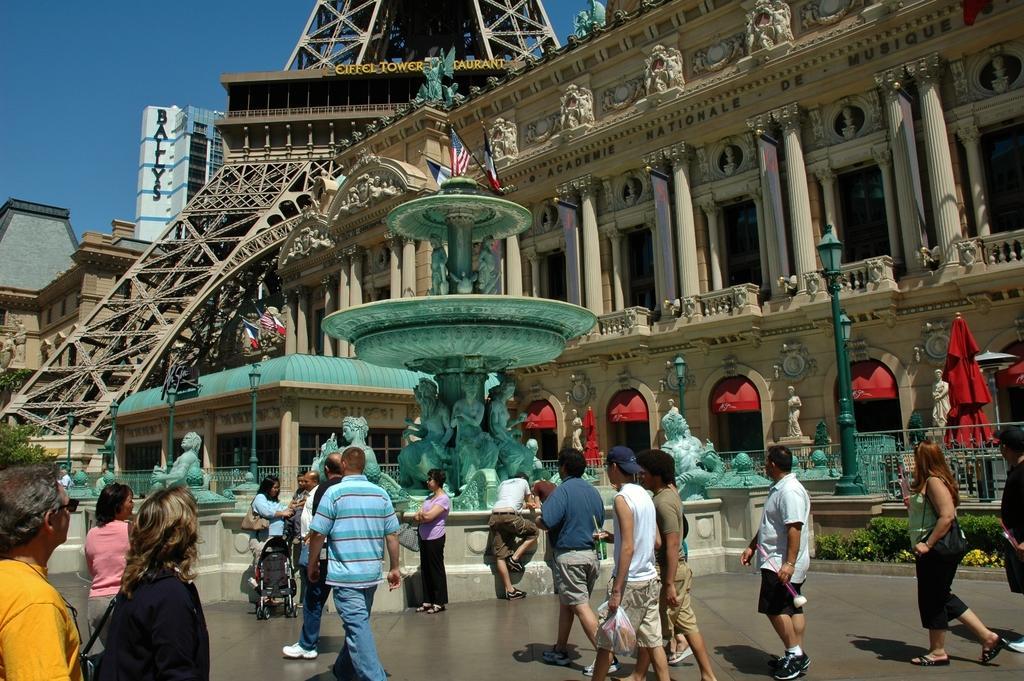In one or two sentences, can you explain what this image depicts? There are people in the foreground area of the image, there are buildings, pillars, a tower, fountain, flag and the sky in the background. 